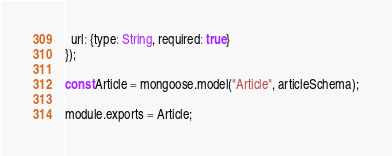<code> <loc_0><loc_0><loc_500><loc_500><_JavaScript_>  url: {type: String, required: true}
});

const Article = mongoose.model("Article", articleSchema);

module.exports = Article;</code> 